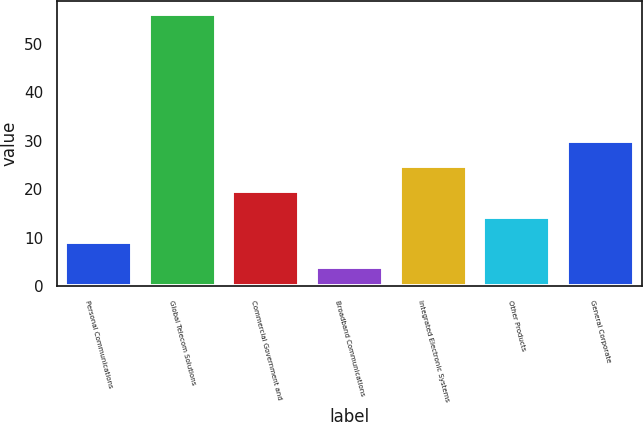Convert chart. <chart><loc_0><loc_0><loc_500><loc_500><bar_chart><fcel>Personal Communications<fcel>Global Telecom Solutions<fcel>Commercial Government and<fcel>Broadband Communications<fcel>Integrated Electronic Systems<fcel>Other Products<fcel>General Corporate<nl><fcel>9.2<fcel>56<fcel>19.6<fcel>4<fcel>24.8<fcel>14.4<fcel>30<nl></chart> 